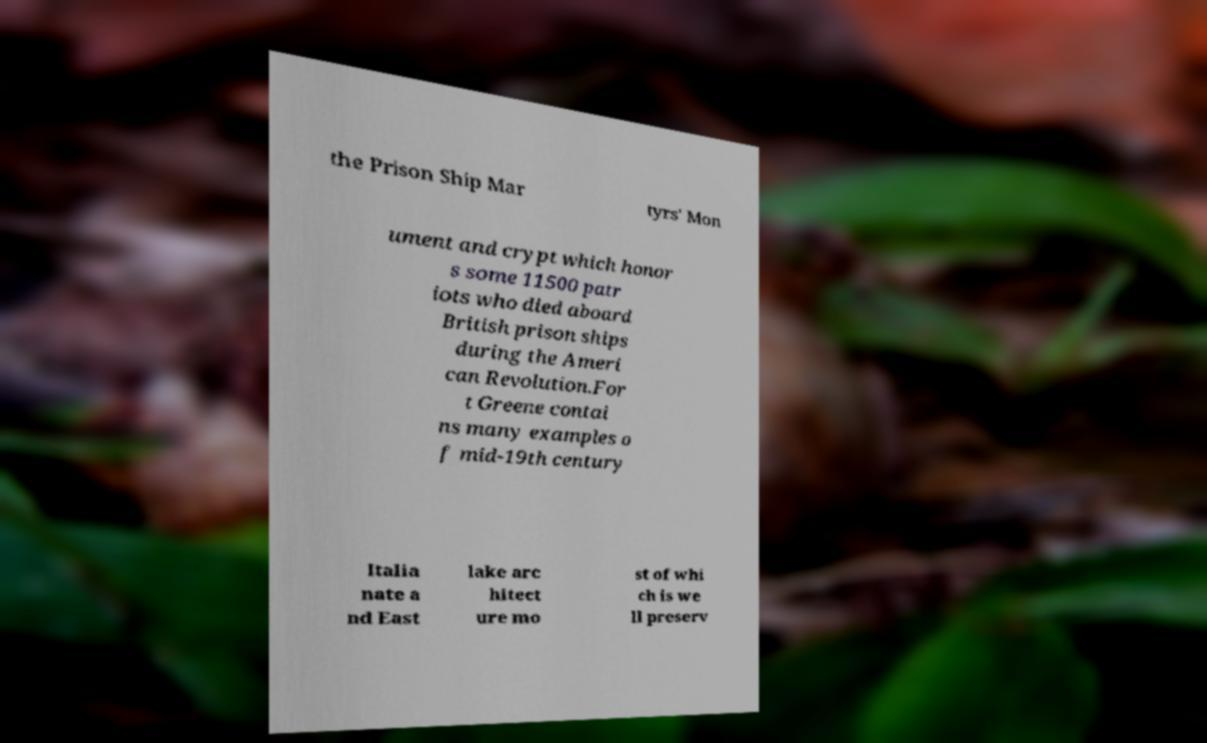Please read and relay the text visible in this image. What does it say? the Prison Ship Mar tyrs' Mon ument and crypt which honor s some 11500 patr iots who died aboard British prison ships during the Ameri can Revolution.For t Greene contai ns many examples o f mid-19th century Italia nate a nd East lake arc hitect ure mo st of whi ch is we ll preserv 